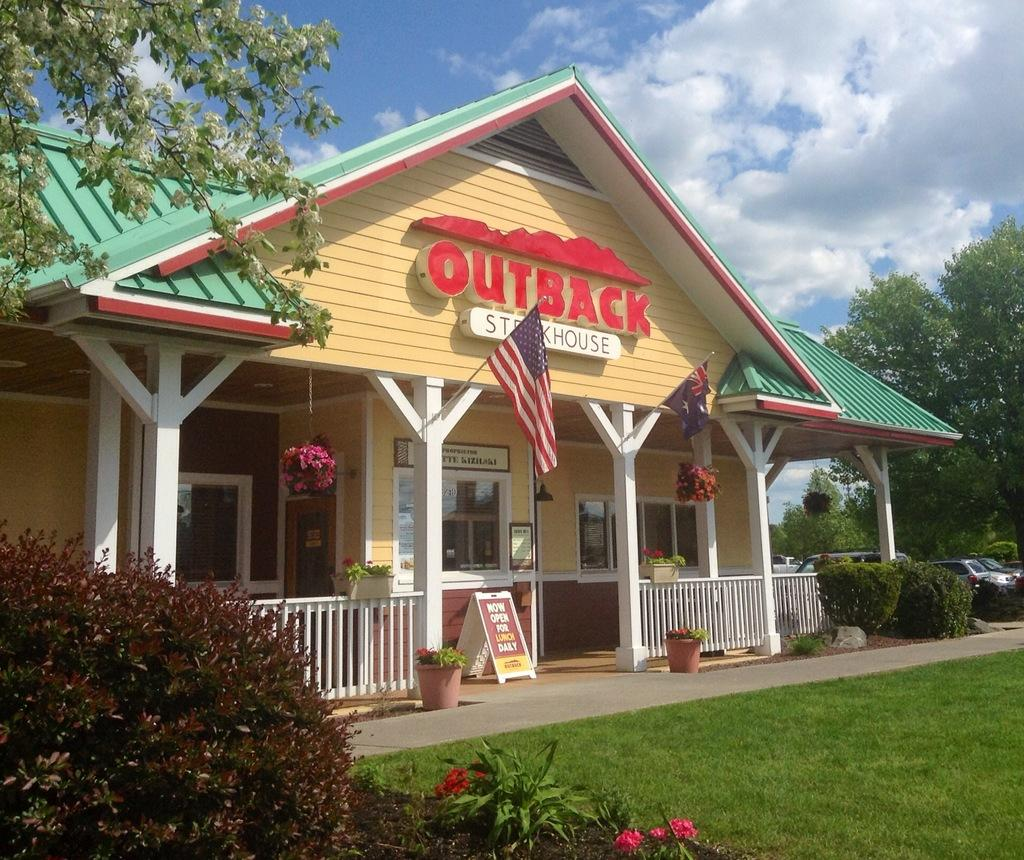What type of vegetation can be seen in the image? There is grass, plants, flowers, and trees in the image. What man-made objects are present in the image? There are cars, flags, boards, a fence, a house, and a sky visible in the background of the image. What can be seen in the sky in the image? There are clouds in the sky. What type of discovery was made by the sheep in the image? There are no sheep present in the image, so no discovery can be attributed to them. 